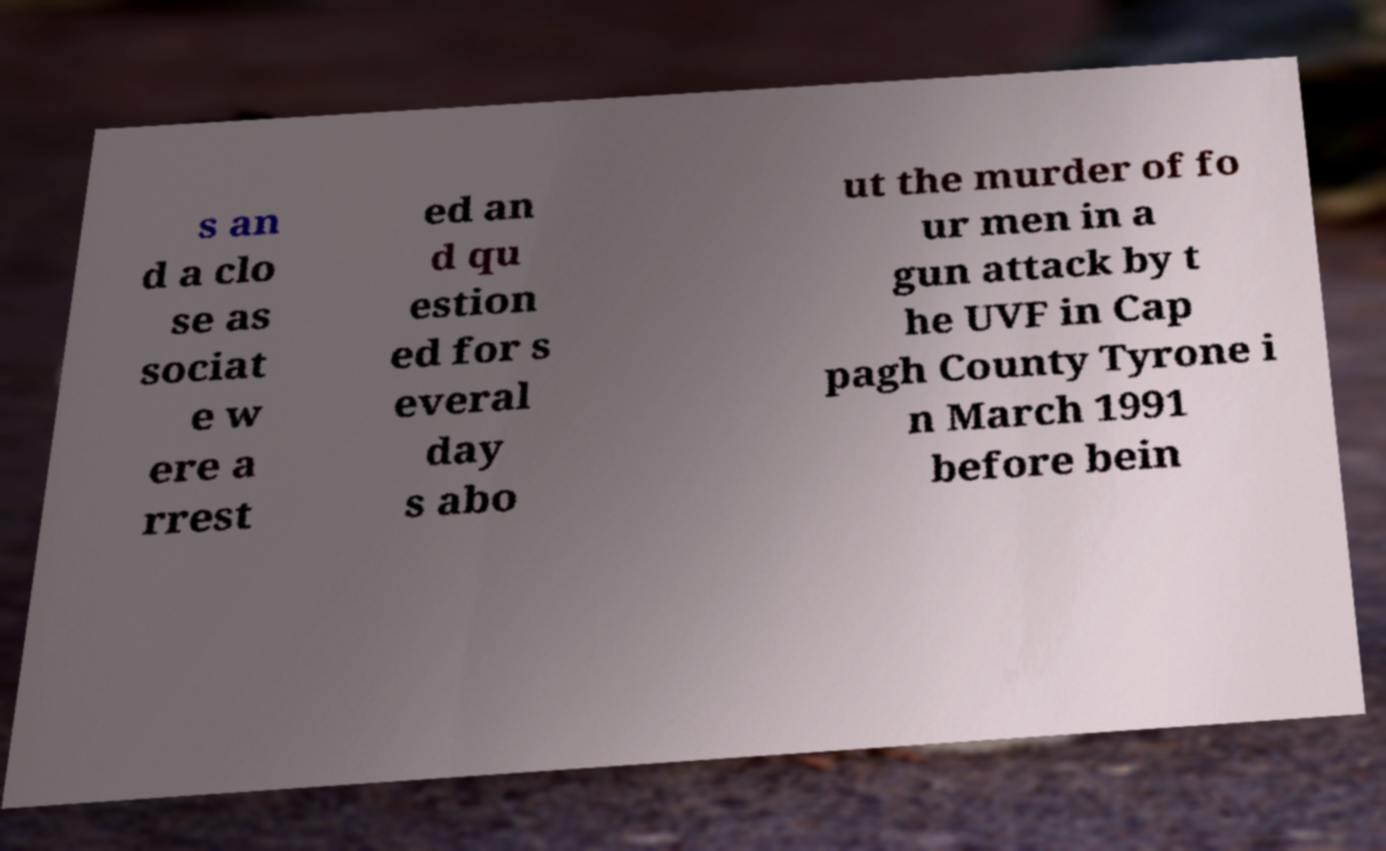There's text embedded in this image that I need extracted. Can you transcribe it verbatim? s an d a clo se as sociat e w ere a rrest ed an d qu estion ed for s everal day s abo ut the murder of fo ur men in a gun attack by t he UVF in Cap pagh County Tyrone i n March 1991 before bein 